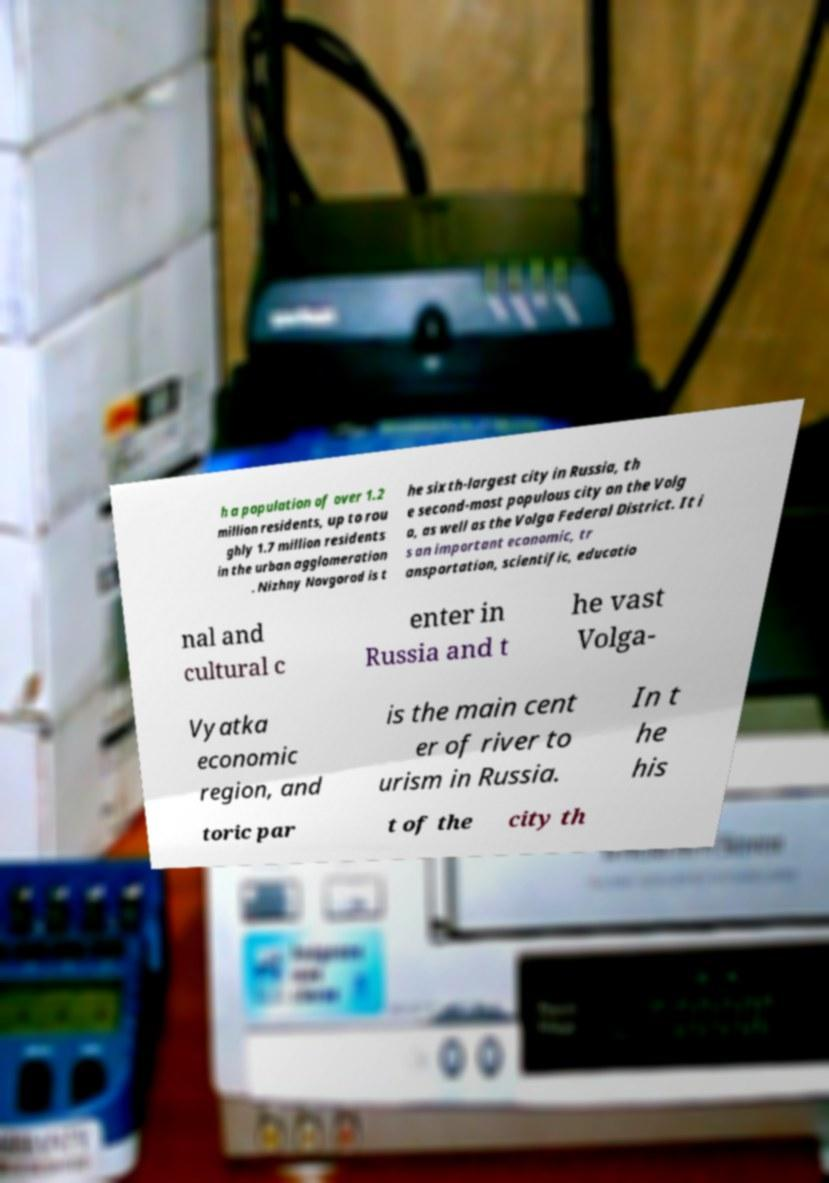Please identify and transcribe the text found in this image. h a population of over 1.2 million residents, up to rou ghly 1.7 million residents in the urban agglomeration . Nizhny Novgorod is t he sixth-largest city in Russia, th e second-most populous city on the Volg a, as well as the Volga Federal District. It i s an important economic, tr ansportation, scientific, educatio nal and cultural c enter in Russia and t he vast Volga- Vyatka economic region, and is the main cent er of river to urism in Russia. In t he his toric par t of the city th 